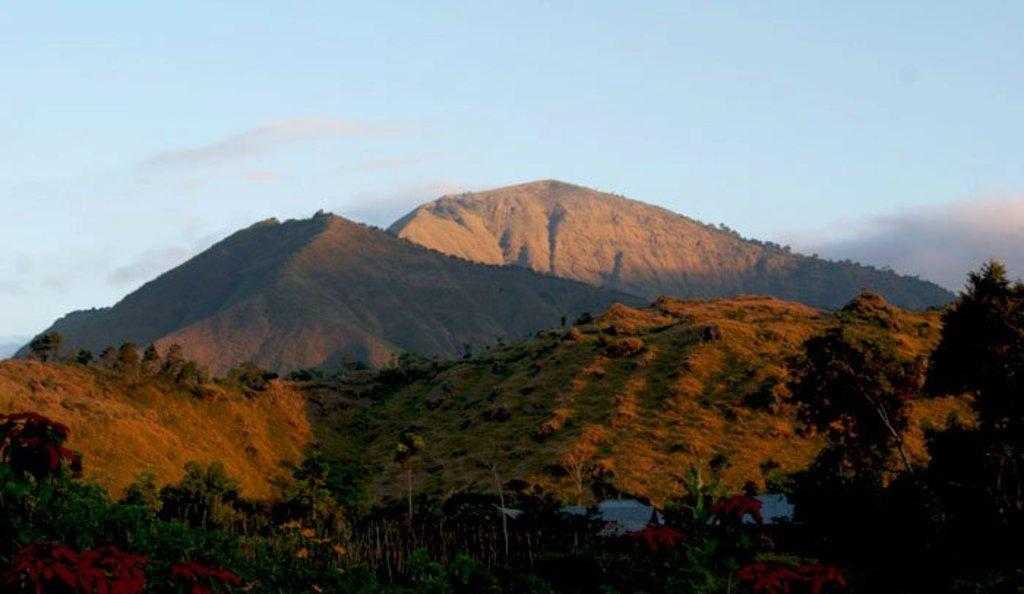What type of vegetation can be seen in the image? There are trees in the image. What color are the trees? The trees are green in color. What can be seen in the background of the image? There are mountains visible in the background of the image. What colors are present in the sky in the image? The sky is blue and white in color. How many feet are visible in the image? There are no feet present in the image. Can you spot any ants crawling on the trees in the image? There are no ants visible in the image. 